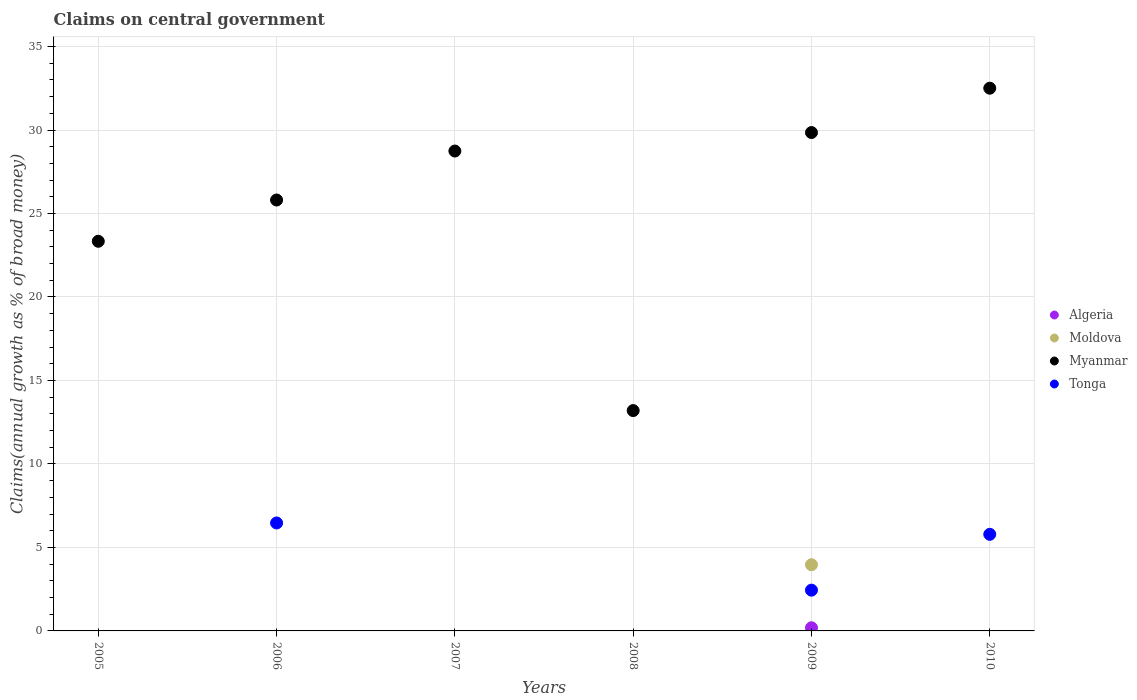Across all years, what is the maximum percentage of broad money claimed on centeral government in Myanmar?
Your response must be concise. 32.5. What is the total percentage of broad money claimed on centeral government in Tonga in the graph?
Your answer should be compact. 14.69. What is the difference between the percentage of broad money claimed on centeral government in Myanmar in 2005 and that in 2007?
Give a very brief answer. -5.4. What is the difference between the percentage of broad money claimed on centeral government in Moldova in 2006 and the percentage of broad money claimed on centeral government in Algeria in 2005?
Your answer should be very brief. 0. What is the average percentage of broad money claimed on centeral government in Moldova per year?
Provide a succinct answer. 0.66. In how many years, is the percentage of broad money claimed on centeral government in Moldova greater than 20 %?
Your answer should be very brief. 0. What is the ratio of the percentage of broad money claimed on centeral government in Tonga in 2006 to that in 2009?
Provide a short and direct response. 2.65. Is the percentage of broad money claimed on centeral government in Myanmar in 2005 less than that in 2008?
Provide a succinct answer. No. What is the difference between the highest and the second highest percentage of broad money claimed on centeral government in Tonga?
Provide a succinct answer. 0.68. What is the difference between the highest and the lowest percentage of broad money claimed on centeral government in Myanmar?
Make the answer very short. 19.31. In how many years, is the percentage of broad money claimed on centeral government in Algeria greater than the average percentage of broad money claimed on centeral government in Algeria taken over all years?
Your answer should be very brief. 1. Is the sum of the percentage of broad money claimed on centeral government in Myanmar in 2006 and 2008 greater than the maximum percentage of broad money claimed on centeral government in Moldova across all years?
Ensure brevity in your answer.  Yes. Is it the case that in every year, the sum of the percentage of broad money claimed on centeral government in Moldova and percentage of broad money claimed on centeral government in Algeria  is greater than the percentage of broad money claimed on centeral government in Tonga?
Provide a short and direct response. No. Does the percentage of broad money claimed on centeral government in Algeria monotonically increase over the years?
Keep it short and to the point. No. Is the percentage of broad money claimed on centeral government in Moldova strictly less than the percentage of broad money claimed on centeral government in Tonga over the years?
Provide a short and direct response. No. Are the values on the major ticks of Y-axis written in scientific E-notation?
Offer a very short reply. No. Does the graph contain any zero values?
Your answer should be very brief. Yes. How many legend labels are there?
Your answer should be very brief. 4. What is the title of the graph?
Provide a short and direct response. Claims on central government. Does "St. Lucia" appear as one of the legend labels in the graph?
Provide a succinct answer. No. What is the label or title of the X-axis?
Offer a terse response. Years. What is the label or title of the Y-axis?
Give a very brief answer. Claims(annual growth as % of broad money). What is the Claims(annual growth as % of broad money) in Moldova in 2005?
Provide a short and direct response. 0. What is the Claims(annual growth as % of broad money) of Myanmar in 2005?
Provide a short and direct response. 23.34. What is the Claims(annual growth as % of broad money) of Tonga in 2005?
Provide a short and direct response. 0. What is the Claims(annual growth as % of broad money) in Myanmar in 2006?
Keep it short and to the point. 25.81. What is the Claims(annual growth as % of broad money) in Tonga in 2006?
Provide a succinct answer. 6.47. What is the Claims(annual growth as % of broad money) of Myanmar in 2007?
Offer a terse response. 28.74. What is the Claims(annual growth as % of broad money) in Myanmar in 2008?
Your answer should be compact. 13.2. What is the Claims(annual growth as % of broad money) in Tonga in 2008?
Your answer should be compact. 0. What is the Claims(annual growth as % of broad money) of Algeria in 2009?
Your response must be concise. 0.19. What is the Claims(annual growth as % of broad money) of Moldova in 2009?
Your response must be concise. 3.96. What is the Claims(annual growth as % of broad money) of Myanmar in 2009?
Your answer should be very brief. 29.85. What is the Claims(annual growth as % of broad money) in Tonga in 2009?
Provide a short and direct response. 2.44. What is the Claims(annual growth as % of broad money) of Moldova in 2010?
Your answer should be compact. 0. What is the Claims(annual growth as % of broad money) in Myanmar in 2010?
Your answer should be compact. 32.5. What is the Claims(annual growth as % of broad money) of Tonga in 2010?
Your response must be concise. 5.79. Across all years, what is the maximum Claims(annual growth as % of broad money) of Algeria?
Keep it short and to the point. 0.19. Across all years, what is the maximum Claims(annual growth as % of broad money) of Moldova?
Offer a terse response. 3.96. Across all years, what is the maximum Claims(annual growth as % of broad money) of Myanmar?
Keep it short and to the point. 32.5. Across all years, what is the maximum Claims(annual growth as % of broad money) in Tonga?
Keep it short and to the point. 6.47. Across all years, what is the minimum Claims(annual growth as % of broad money) in Algeria?
Your answer should be very brief. 0. Across all years, what is the minimum Claims(annual growth as % of broad money) of Myanmar?
Ensure brevity in your answer.  13.2. Across all years, what is the minimum Claims(annual growth as % of broad money) in Tonga?
Offer a very short reply. 0. What is the total Claims(annual growth as % of broad money) in Algeria in the graph?
Offer a terse response. 0.19. What is the total Claims(annual growth as % of broad money) of Moldova in the graph?
Make the answer very short. 3.96. What is the total Claims(annual growth as % of broad money) of Myanmar in the graph?
Keep it short and to the point. 153.43. What is the total Claims(annual growth as % of broad money) of Tonga in the graph?
Offer a terse response. 14.69. What is the difference between the Claims(annual growth as % of broad money) of Myanmar in 2005 and that in 2006?
Your response must be concise. -2.47. What is the difference between the Claims(annual growth as % of broad money) in Myanmar in 2005 and that in 2007?
Make the answer very short. -5.41. What is the difference between the Claims(annual growth as % of broad money) in Myanmar in 2005 and that in 2008?
Give a very brief answer. 10.14. What is the difference between the Claims(annual growth as % of broad money) of Myanmar in 2005 and that in 2009?
Keep it short and to the point. -6.51. What is the difference between the Claims(annual growth as % of broad money) in Myanmar in 2005 and that in 2010?
Make the answer very short. -9.17. What is the difference between the Claims(annual growth as % of broad money) in Myanmar in 2006 and that in 2007?
Give a very brief answer. -2.93. What is the difference between the Claims(annual growth as % of broad money) in Myanmar in 2006 and that in 2008?
Make the answer very short. 12.61. What is the difference between the Claims(annual growth as % of broad money) of Myanmar in 2006 and that in 2009?
Offer a terse response. -4.04. What is the difference between the Claims(annual growth as % of broad money) of Tonga in 2006 and that in 2009?
Your response must be concise. 4.02. What is the difference between the Claims(annual growth as % of broad money) of Myanmar in 2006 and that in 2010?
Your answer should be compact. -6.7. What is the difference between the Claims(annual growth as % of broad money) in Tonga in 2006 and that in 2010?
Your answer should be very brief. 0.68. What is the difference between the Claims(annual growth as % of broad money) of Myanmar in 2007 and that in 2008?
Your answer should be compact. 15.54. What is the difference between the Claims(annual growth as % of broad money) in Myanmar in 2007 and that in 2009?
Give a very brief answer. -1.11. What is the difference between the Claims(annual growth as % of broad money) of Myanmar in 2007 and that in 2010?
Provide a short and direct response. -3.76. What is the difference between the Claims(annual growth as % of broad money) in Myanmar in 2008 and that in 2009?
Give a very brief answer. -16.65. What is the difference between the Claims(annual growth as % of broad money) in Myanmar in 2008 and that in 2010?
Your response must be concise. -19.31. What is the difference between the Claims(annual growth as % of broad money) in Myanmar in 2009 and that in 2010?
Give a very brief answer. -2.66. What is the difference between the Claims(annual growth as % of broad money) in Tonga in 2009 and that in 2010?
Make the answer very short. -3.34. What is the difference between the Claims(annual growth as % of broad money) of Myanmar in 2005 and the Claims(annual growth as % of broad money) of Tonga in 2006?
Give a very brief answer. 16.87. What is the difference between the Claims(annual growth as % of broad money) in Myanmar in 2005 and the Claims(annual growth as % of broad money) in Tonga in 2009?
Your response must be concise. 20.89. What is the difference between the Claims(annual growth as % of broad money) in Myanmar in 2005 and the Claims(annual growth as % of broad money) in Tonga in 2010?
Provide a short and direct response. 17.55. What is the difference between the Claims(annual growth as % of broad money) in Myanmar in 2006 and the Claims(annual growth as % of broad money) in Tonga in 2009?
Offer a very short reply. 23.37. What is the difference between the Claims(annual growth as % of broad money) in Myanmar in 2006 and the Claims(annual growth as % of broad money) in Tonga in 2010?
Ensure brevity in your answer.  20.02. What is the difference between the Claims(annual growth as % of broad money) of Myanmar in 2007 and the Claims(annual growth as % of broad money) of Tonga in 2009?
Your answer should be very brief. 26.3. What is the difference between the Claims(annual growth as % of broad money) of Myanmar in 2007 and the Claims(annual growth as % of broad money) of Tonga in 2010?
Your answer should be very brief. 22.96. What is the difference between the Claims(annual growth as % of broad money) in Myanmar in 2008 and the Claims(annual growth as % of broad money) in Tonga in 2009?
Keep it short and to the point. 10.76. What is the difference between the Claims(annual growth as % of broad money) of Myanmar in 2008 and the Claims(annual growth as % of broad money) of Tonga in 2010?
Your answer should be compact. 7.41. What is the difference between the Claims(annual growth as % of broad money) of Algeria in 2009 and the Claims(annual growth as % of broad money) of Myanmar in 2010?
Offer a terse response. -32.32. What is the difference between the Claims(annual growth as % of broad money) in Algeria in 2009 and the Claims(annual growth as % of broad money) in Tonga in 2010?
Make the answer very short. -5.6. What is the difference between the Claims(annual growth as % of broad money) of Moldova in 2009 and the Claims(annual growth as % of broad money) of Myanmar in 2010?
Give a very brief answer. -28.54. What is the difference between the Claims(annual growth as % of broad money) in Moldova in 2009 and the Claims(annual growth as % of broad money) in Tonga in 2010?
Your response must be concise. -1.82. What is the difference between the Claims(annual growth as % of broad money) of Myanmar in 2009 and the Claims(annual growth as % of broad money) of Tonga in 2010?
Your answer should be very brief. 24.06. What is the average Claims(annual growth as % of broad money) in Algeria per year?
Offer a very short reply. 0.03. What is the average Claims(annual growth as % of broad money) of Moldova per year?
Offer a terse response. 0.66. What is the average Claims(annual growth as % of broad money) in Myanmar per year?
Offer a terse response. 25.57. What is the average Claims(annual growth as % of broad money) of Tonga per year?
Make the answer very short. 2.45. In the year 2006, what is the difference between the Claims(annual growth as % of broad money) in Myanmar and Claims(annual growth as % of broad money) in Tonga?
Provide a short and direct response. 19.34. In the year 2009, what is the difference between the Claims(annual growth as % of broad money) in Algeria and Claims(annual growth as % of broad money) in Moldova?
Ensure brevity in your answer.  -3.77. In the year 2009, what is the difference between the Claims(annual growth as % of broad money) of Algeria and Claims(annual growth as % of broad money) of Myanmar?
Offer a terse response. -29.66. In the year 2009, what is the difference between the Claims(annual growth as % of broad money) in Algeria and Claims(annual growth as % of broad money) in Tonga?
Your answer should be compact. -2.25. In the year 2009, what is the difference between the Claims(annual growth as % of broad money) of Moldova and Claims(annual growth as % of broad money) of Myanmar?
Provide a short and direct response. -25.88. In the year 2009, what is the difference between the Claims(annual growth as % of broad money) of Moldova and Claims(annual growth as % of broad money) of Tonga?
Ensure brevity in your answer.  1.52. In the year 2009, what is the difference between the Claims(annual growth as % of broad money) in Myanmar and Claims(annual growth as % of broad money) in Tonga?
Your answer should be very brief. 27.41. In the year 2010, what is the difference between the Claims(annual growth as % of broad money) in Myanmar and Claims(annual growth as % of broad money) in Tonga?
Give a very brief answer. 26.72. What is the ratio of the Claims(annual growth as % of broad money) of Myanmar in 2005 to that in 2006?
Give a very brief answer. 0.9. What is the ratio of the Claims(annual growth as % of broad money) of Myanmar in 2005 to that in 2007?
Your response must be concise. 0.81. What is the ratio of the Claims(annual growth as % of broad money) of Myanmar in 2005 to that in 2008?
Your response must be concise. 1.77. What is the ratio of the Claims(annual growth as % of broad money) in Myanmar in 2005 to that in 2009?
Provide a succinct answer. 0.78. What is the ratio of the Claims(annual growth as % of broad money) of Myanmar in 2005 to that in 2010?
Make the answer very short. 0.72. What is the ratio of the Claims(annual growth as % of broad money) in Myanmar in 2006 to that in 2007?
Provide a succinct answer. 0.9. What is the ratio of the Claims(annual growth as % of broad money) in Myanmar in 2006 to that in 2008?
Give a very brief answer. 1.96. What is the ratio of the Claims(annual growth as % of broad money) of Myanmar in 2006 to that in 2009?
Provide a succinct answer. 0.86. What is the ratio of the Claims(annual growth as % of broad money) of Tonga in 2006 to that in 2009?
Ensure brevity in your answer.  2.65. What is the ratio of the Claims(annual growth as % of broad money) in Myanmar in 2006 to that in 2010?
Give a very brief answer. 0.79. What is the ratio of the Claims(annual growth as % of broad money) of Tonga in 2006 to that in 2010?
Offer a terse response. 1.12. What is the ratio of the Claims(annual growth as % of broad money) of Myanmar in 2007 to that in 2008?
Provide a short and direct response. 2.18. What is the ratio of the Claims(annual growth as % of broad money) of Myanmar in 2007 to that in 2009?
Ensure brevity in your answer.  0.96. What is the ratio of the Claims(annual growth as % of broad money) in Myanmar in 2007 to that in 2010?
Provide a short and direct response. 0.88. What is the ratio of the Claims(annual growth as % of broad money) of Myanmar in 2008 to that in 2009?
Offer a terse response. 0.44. What is the ratio of the Claims(annual growth as % of broad money) of Myanmar in 2008 to that in 2010?
Keep it short and to the point. 0.41. What is the ratio of the Claims(annual growth as % of broad money) in Myanmar in 2009 to that in 2010?
Ensure brevity in your answer.  0.92. What is the ratio of the Claims(annual growth as % of broad money) in Tonga in 2009 to that in 2010?
Provide a succinct answer. 0.42. What is the difference between the highest and the second highest Claims(annual growth as % of broad money) of Myanmar?
Offer a very short reply. 2.66. What is the difference between the highest and the second highest Claims(annual growth as % of broad money) of Tonga?
Ensure brevity in your answer.  0.68. What is the difference between the highest and the lowest Claims(annual growth as % of broad money) in Algeria?
Keep it short and to the point. 0.19. What is the difference between the highest and the lowest Claims(annual growth as % of broad money) in Moldova?
Give a very brief answer. 3.96. What is the difference between the highest and the lowest Claims(annual growth as % of broad money) in Myanmar?
Provide a succinct answer. 19.31. What is the difference between the highest and the lowest Claims(annual growth as % of broad money) of Tonga?
Keep it short and to the point. 6.47. 